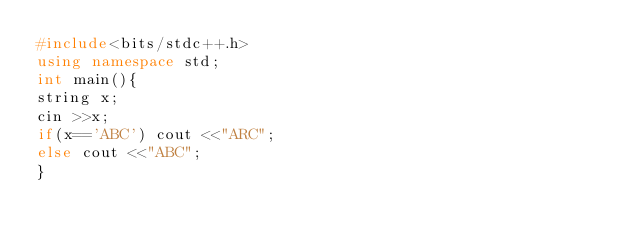Convert code to text. <code><loc_0><loc_0><loc_500><loc_500><_C++_>#include<bits/stdc++.h>
using namespace std;
int main(){
string x;
cin >>x;
if(x=='ABC') cout <<"ARC";
else cout <<"ABC";
}
</code> 